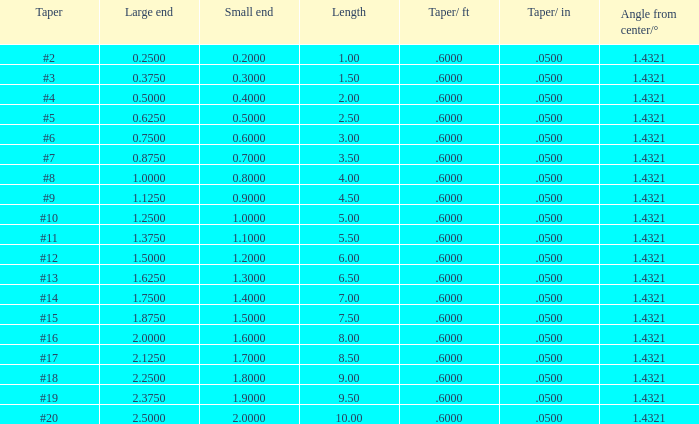Which Angle from center/° has a Taper/ft smaller than 0.6000000000000001? 19.0. 